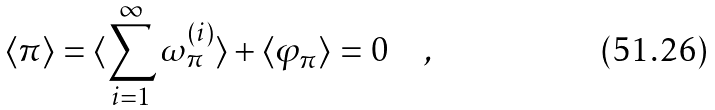<formula> <loc_0><loc_0><loc_500><loc_500>\langle \pi \rangle = \langle \sum _ { i = 1 } ^ { \infty } \omega _ { \pi } ^ { ( i ) } \rangle + \langle \varphi _ { \pi } \rangle = 0 \quad ,</formula> 